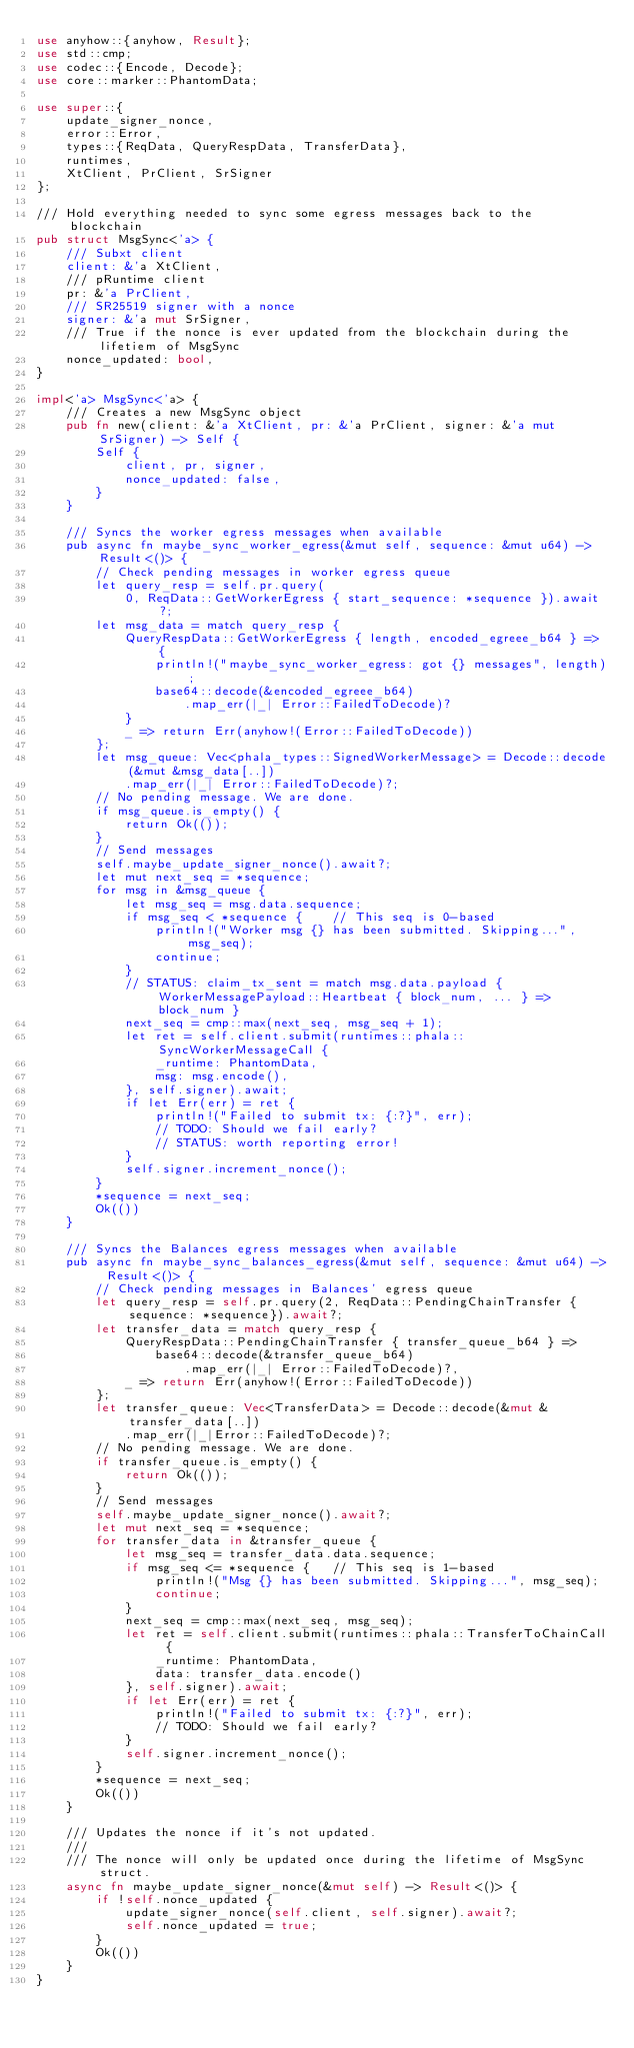Convert code to text. <code><loc_0><loc_0><loc_500><loc_500><_Rust_>use anyhow::{anyhow, Result};
use std::cmp;
use codec::{Encode, Decode};
use core::marker::PhantomData;

use super::{
    update_signer_nonce,
    error::Error,
    types::{ReqData, QueryRespData, TransferData},
    runtimes,
    XtClient, PrClient, SrSigner
};

/// Hold everything needed to sync some egress messages back to the blockchain
pub struct MsgSync<'a> {
    /// Subxt client
    client: &'a XtClient,
    /// pRuntime client
    pr: &'a PrClient,
    /// SR25519 signer with a nonce
    signer: &'a mut SrSigner,
    /// True if the nonce is ever updated from the blockchain during the lifetiem of MsgSync
    nonce_updated: bool,
}

impl<'a> MsgSync<'a> {
    /// Creates a new MsgSync object
    pub fn new(client: &'a XtClient, pr: &'a PrClient, signer: &'a mut SrSigner) -> Self {
        Self {
            client, pr, signer,
            nonce_updated: false,
        }
    }

    /// Syncs the worker egress messages when available
    pub async fn maybe_sync_worker_egress(&mut self, sequence: &mut u64) -> Result<()> {
        // Check pending messages in worker egress queue
        let query_resp = self.pr.query(
            0, ReqData::GetWorkerEgress { start_sequence: *sequence }).await?;
        let msg_data = match query_resp {
            QueryRespData::GetWorkerEgress { length, encoded_egreee_b64 } => {
                println!("maybe_sync_worker_egress: got {} messages", length);
                base64::decode(&encoded_egreee_b64)
                    .map_err(|_| Error::FailedToDecode)?
            }
            _ => return Err(anyhow!(Error::FailedToDecode))
        };
        let msg_queue: Vec<phala_types::SignedWorkerMessage> = Decode::decode(&mut &msg_data[..])
            .map_err(|_| Error::FailedToDecode)?;
        // No pending message. We are done.
        if msg_queue.is_empty() {
            return Ok(());
        }
        // Send messages
        self.maybe_update_signer_nonce().await?;
        let mut next_seq = *sequence;
        for msg in &msg_queue {
            let msg_seq = msg.data.sequence;
            if msg_seq < *sequence {    // This seq is 0-based
                println!("Worker msg {} has been submitted. Skipping...", msg_seq);
                continue;
            }
            // STATUS: claim_tx_sent = match msg.data.payload { WorkerMessagePayload::Heartbeat { block_num, ... } => block_num }
            next_seq = cmp::max(next_seq, msg_seq + 1);
            let ret = self.client.submit(runtimes::phala::SyncWorkerMessageCall {
                _runtime: PhantomData,
                msg: msg.encode(),
            }, self.signer).await;
            if let Err(err) = ret {
                println!("Failed to submit tx: {:?}", err);
                // TODO: Should we fail early?
                // STATUS: worth reporting error!
            }
            self.signer.increment_nonce();
        }
        *sequence = next_seq;
        Ok(())
    }

    /// Syncs the Balances egress messages when available
    pub async fn maybe_sync_balances_egress(&mut self, sequence: &mut u64) -> Result<()> {
        // Check pending messages in Balances' egress queue
        let query_resp = self.pr.query(2, ReqData::PendingChainTransfer {sequence: *sequence}).await?;
        let transfer_data = match query_resp {
            QueryRespData::PendingChainTransfer { transfer_queue_b64 } =>
                base64::decode(&transfer_queue_b64)
                    .map_err(|_| Error::FailedToDecode)?,
            _ => return Err(anyhow!(Error::FailedToDecode))
        };
        let transfer_queue: Vec<TransferData> = Decode::decode(&mut &transfer_data[..])
            .map_err(|_|Error::FailedToDecode)?;
        // No pending message. We are done.
        if transfer_queue.is_empty() {
            return Ok(());
        }
        // Send messages
        self.maybe_update_signer_nonce().await?;
        let mut next_seq = *sequence;
        for transfer_data in &transfer_queue {
            let msg_seq = transfer_data.data.sequence;
            if msg_seq <= *sequence {   // This seq is 1-based
                println!("Msg {} has been submitted. Skipping...", msg_seq);
                continue;
            }
            next_seq = cmp::max(next_seq, msg_seq);
            let ret = self.client.submit(runtimes::phala::TransferToChainCall {
                _runtime: PhantomData,
                data: transfer_data.encode()
            }, self.signer).await;
            if let Err(err) = ret {
                println!("Failed to submit tx: {:?}", err);
                // TODO: Should we fail early?
            }
            self.signer.increment_nonce();
        }
        *sequence = next_seq;
        Ok(())
    }

    /// Updates the nonce if it's not updated.
    ///
    /// The nonce will only be updated once during the lifetime of MsgSync struct.
    async fn maybe_update_signer_nonce(&mut self) -> Result<()> {
        if !self.nonce_updated {
            update_signer_nonce(self.client, self.signer).await?;
            self.nonce_updated = true;
        }
        Ok(())
    }
}
</code> 